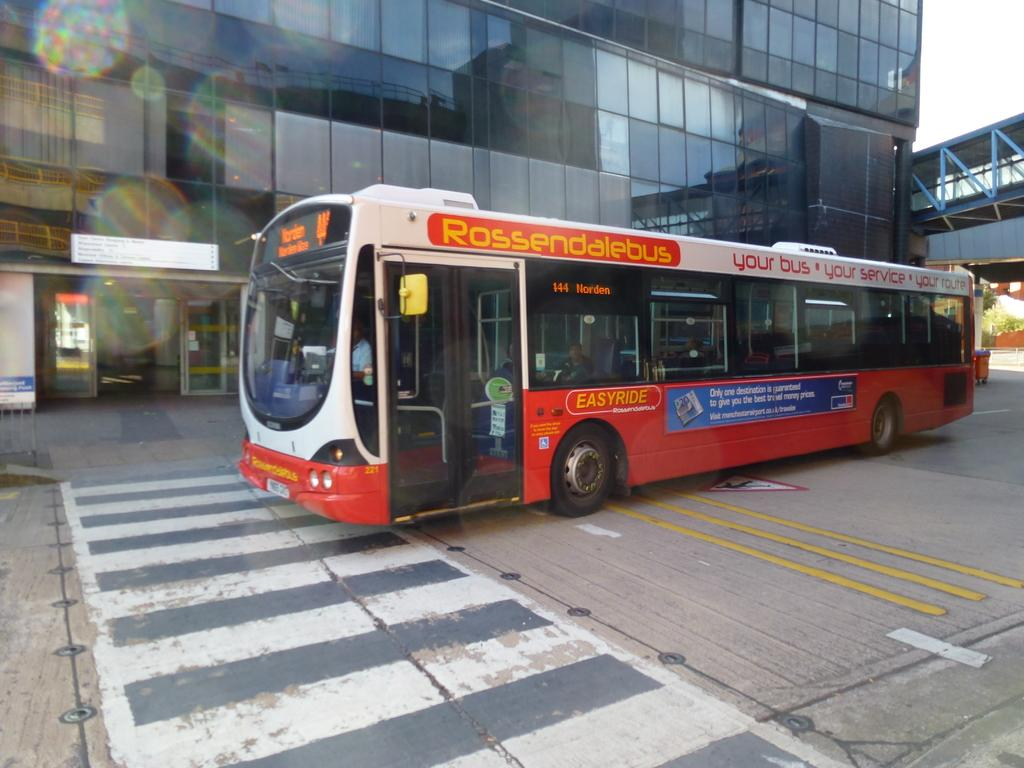<image>
Provide a brief description of the given image. An orange bus has Rossendalebus written in yellow on the top 